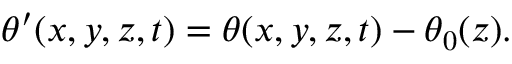Convert formula to latex. <formula><loc_0><loc_0><loc_500><loc_500>\begin{array} { r } { \theta ^ { \prime } ( x , y , z , t ) = \theta ( x , y , z , t ) - \theta _ { 0 } ( z ) . } \end{array}</formula> 